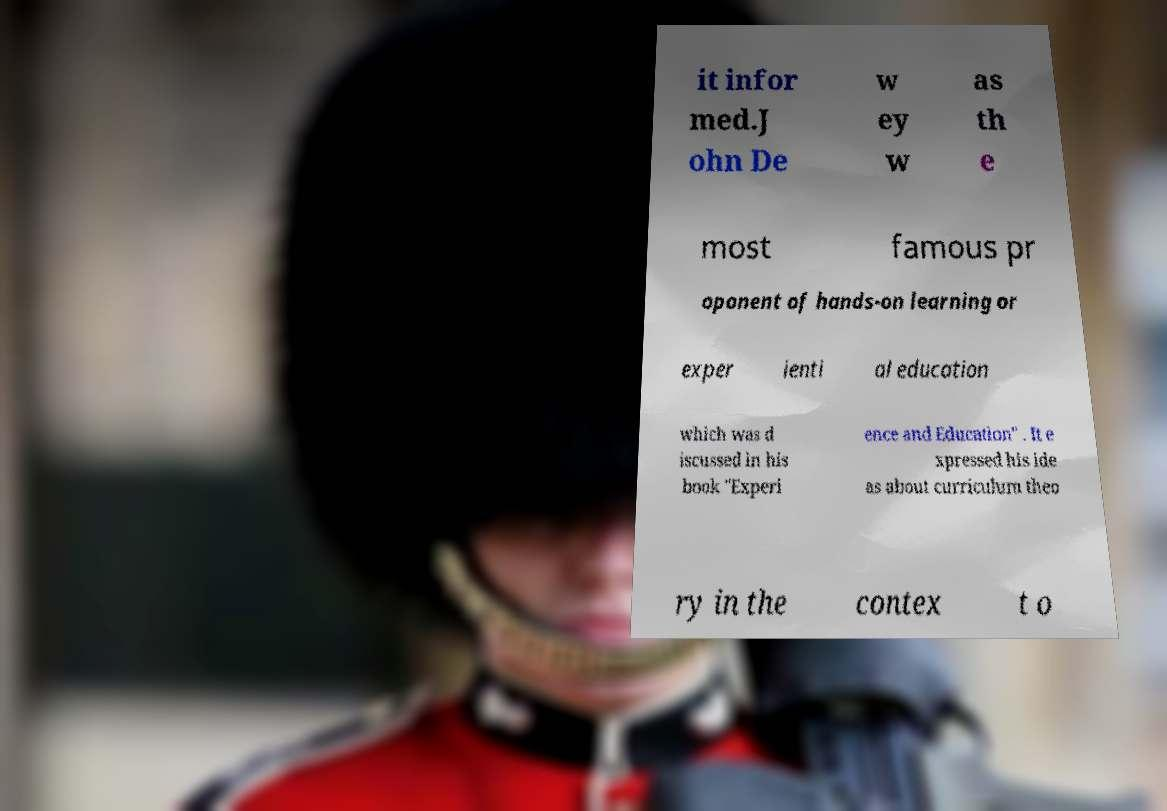Please read and relay the text visible in this image. What does it say? it infor med.J ohn De w ey w as th e most famous pr oponent of hands-on learning or exper ienti al education which was d iscussed in his book "Experi ence and Education" . It e xpressed his ide as about curriculum theo ry in the contex t o 